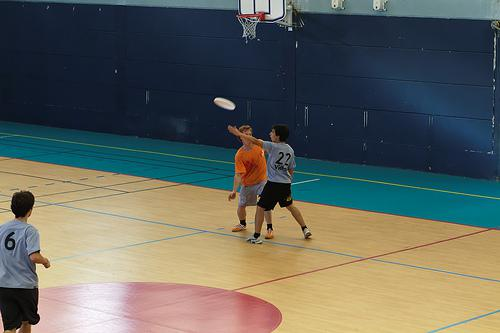Question: what color is the back wall?
Choices:
A. Light green.
B. Red.
C. Dark blue.
D. Yellow.
Answer with the letter. Answer: C Question: what are the people doing?
Choices:
A. Playing volleyball.
B. Playing frisbee.
C. Parkour.
D. Picnicing.
Answer with the letter. Answer: B Question: where was this taken?
Choices:
A. In a gym.
B. In a home.
C. On a track.
D. Outdoors.
Answer with the letter. Answer: A Question: what is the person with light brown hair wearing?
Choices:
A. Green shorts.
B. Sunglasses.
C. A helmet.
D. Grey shorts and an orange shirt.
Answer with the letter. Answer: D Question: how many people can be seen?
Choices:
A. Three.
B. Two.
C. Five.
D. Thirty.
Answer with the letter. Answer: A 